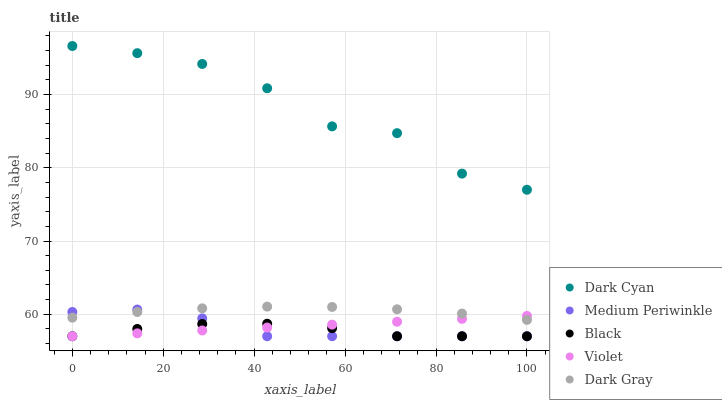Does Black have the minimum area under the curve?
Answer yes or no. Yes. Does Dark Cyan have the maximum area under the curve?
Answer yes or no. Yes. Does Medium Periwinkle have the minimum area under the curve?
Answer yes or no. No. Does Medium Periwinkle have the maximum area under the curve?
Answer yes or no. No. Is Violet the smoothest?
Answer yes or no. Yes. Is Dark Cyan the roughest?
Answer yes or no. Yes. Is Black the smoothest?
Answer yes or no. No. Is Black the roughest?
Answer yes or no. No. Does Black have the lowest value?
Answer yes or no. Yes. Does Dark Gray have the lowest value?
Answer yes or no. No. Does Dark Cyan have the highest value?
Answer yes or no. Yes. Does Medium Periwinkle have the highest value?
Answer yes or no. No. Is Violet less than Dark Cyan?
Answer yes or no. Yes. Is Dark Cyan greater than Violet?
Answer yes or no. Yes. Does Medium Periwinkle intersect Violet?
Answer yes or no. Yes. Is Medium Periwinkle less than Violet?
Answer yes or no. No. Is Medium Periwinkle greater than Violet?
Answer yes or no. No. Does Violet intersect Dark Cyan?
Answer yes or no. No. 